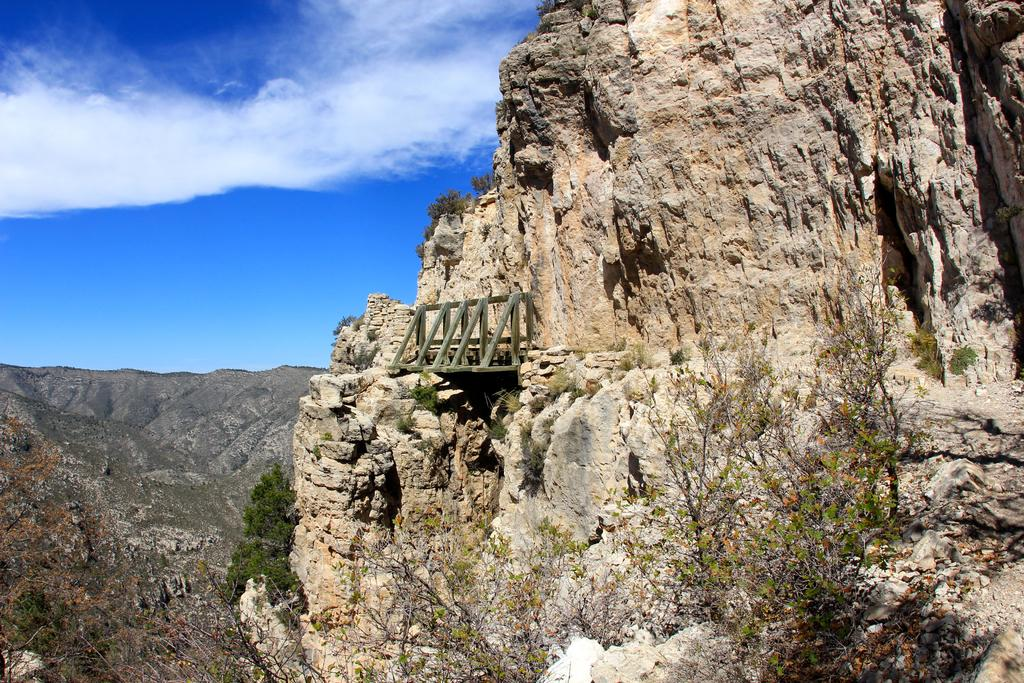What type of natural elements can be seen in the image? There are trees and hills visible in the image. What else can be seen in the sky in the image? There are clouds visible in the image. Where is the crib located in the image? There is no crib present in the image. What type of cake is being served on the hill in the image? There is no cake present in the image; it features trees, hills, and clouds. 